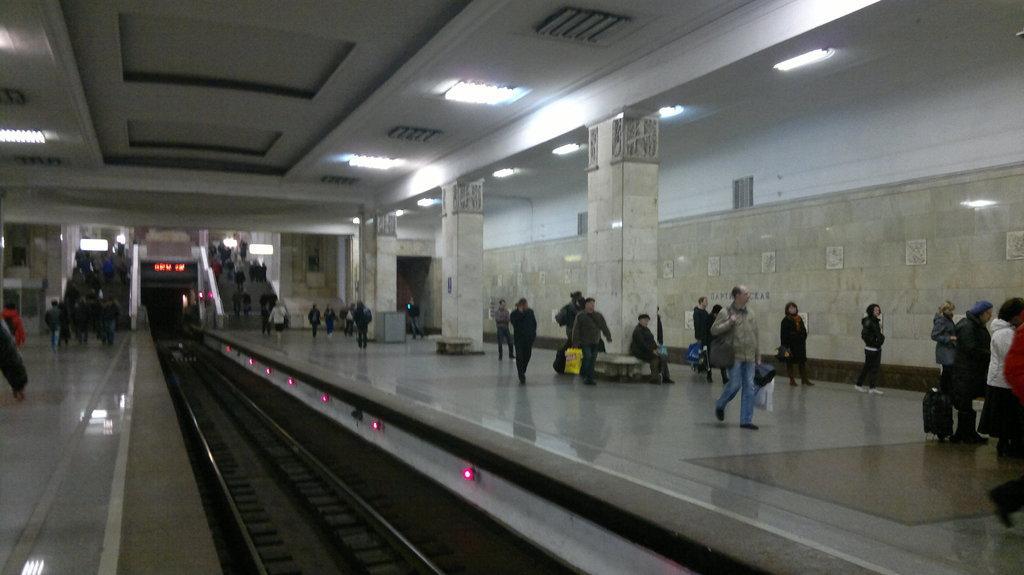How would you summarize this image in a sentence or two? In the foreground of this picture, there is a railway track to which persons are walking on either side of the platform and we can also see pillars, wall, lights and stairs. 